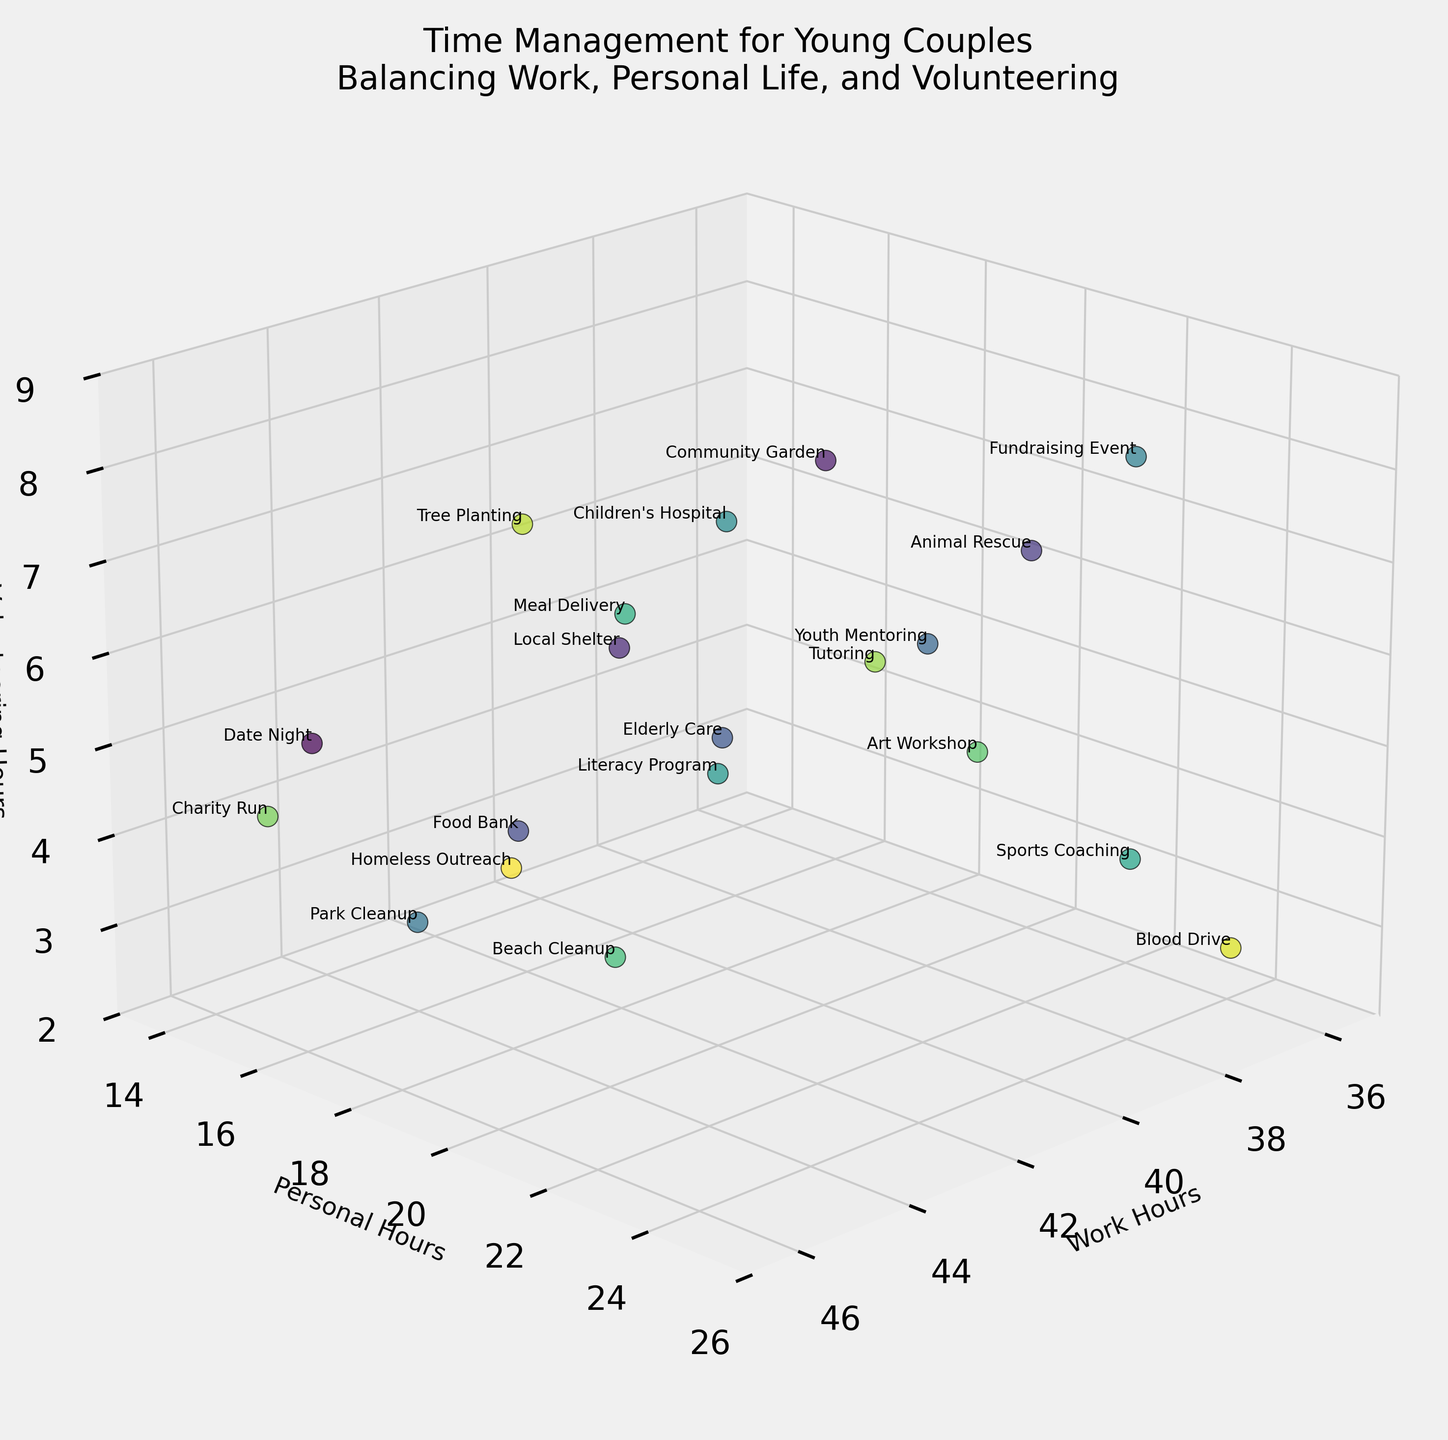How many data points are represented in the figure? To find the number of data points, count the number of labeled points in the figure. Each labeled activity represents a data point. By counting, we find there are 20 data points.
Answer: 20 What are the labels of the axes? The figure displays three axes, each labeled to indicate the type of hours represented. The X-axis is labeled 'Work Hours', the Y-axis is labeled 'Personal Hours', and the Z-axis is labeled 'Volunteering Hours'.
Answer: Work Hours, Personal Hours, Volunteering Hours Which activity has the highest amount of personal hours? Look at the Y-axis (Personal Hours) and identify the point with the highest value on this axis. The activity corresponding to this point is 'Blood Drive' with 25 personal hours.
Answer: Blood Drive What is the range of work hours represented in the figure? Examine the X-axis (Work Hours) to identify the minimum and maximum work hours. The range is from 37 to 45 hours per week.
Answer: 37 to 45 hours How does 'Meal Delivery' compare to 'Tree Planting' in terms of volunteering hours? Find the points for 'Meal Delivery' and 'Tree Planting' and compare their values on the Z-axis (Volunteering Hours). 'Meal Delivery' has 6 volunteering hours, while 'Tree Planting' has 7 volunteering hours. Therefore, 'Tree Planting' has more volunteering hours.
Answer: Tree Planting has more What is the average amount of personal hours spent on 'Fundraising Event' and 'Park Cleanup'? Locate the points for 'Fundraising Event' and 'Park Cleanup'. 'Fundraising Event' has 23 personal hours and 'Park Cleanup' has 16 personal hours. The average is calculated as (23 + 16) / 2 = 19.5 personal hours.
Answer: 19.5 personal hours What's the total number of volunteering hours spent on 'Elderly Care', 'Children's Hospital', and 'Literacy Program'? Identify the volunteering hours for each activity: 'Elderly Care' (5 hours), 'Children's Hospital' (7 hours), and 'Literacy Program' (5 hours). Sum these values: 5 + 7 + 5 = 17 hours.
Answer: 17 hours Which two activities spend the same amount of volunteering hours? Compare the Z-axis (Volunteering Hours) values to find activities with the same amount of hours. 'Date Night' and 'Food Bank' both have 4 volunteering hours.
Answer: Date Night and Food Bank What's the combined work and personal hours for 'Local Shelter'? Add the work hours and personal hours for 'Local Shelter': 42 (work) + 18 (personal) = 60 hours.
Answer: 60 hours 